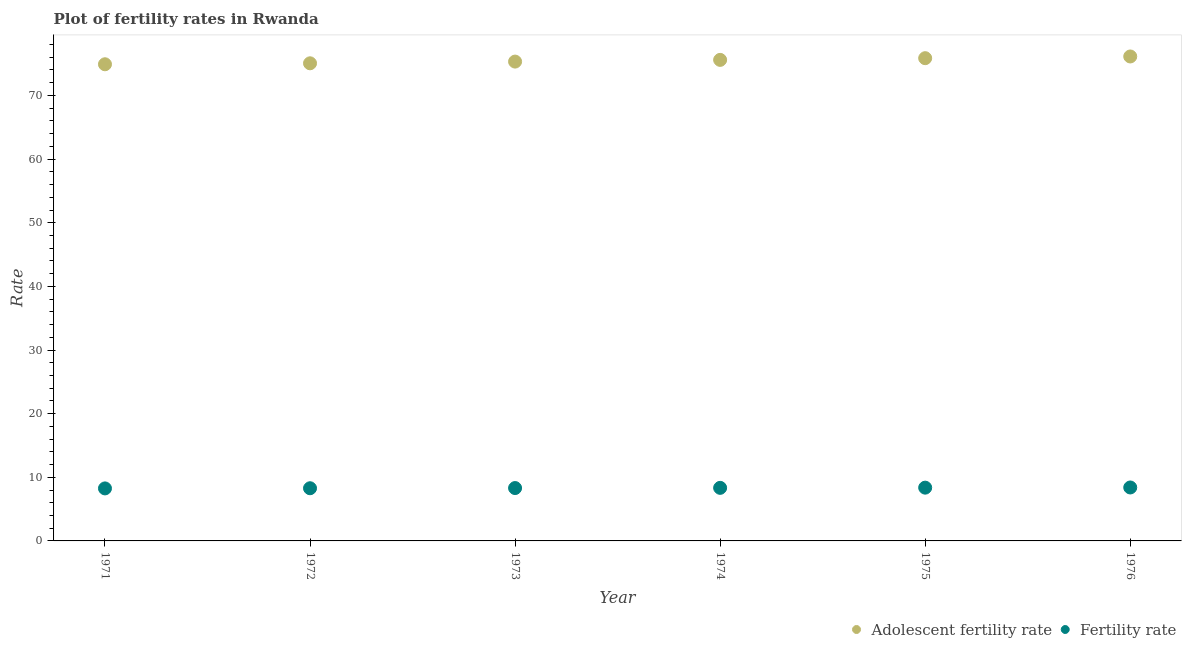What is the fertility rate in 1976?
Keep it short and to the point. 8.4. Across all years, what is the maximum fertility rate?
Your response must be concise. 8.4. Across all years, what is the minimum adolescent fertility rate?
Offer a terse response. 74.9. In which year was the fertility rate maximum?
Ensure brevity in your answer.  1976. In which year was the adolescent fertility rate minimum?
Your response must be concise. 1971. What is the total adolescent fertility rate in the graph?
Your answer should be very brief. 452.85. What is the difference between the fertility rate in 1972 and that in 1973?
Make the answer very short. -0.03. What is the difference between the fertility rate in 1975 and the adolescent fertility rate in 1976?
Your response must be concise. -67.76. What is the average adolescent fertility rate per year?
Your answer should be very brief. 75.47. In the year 1971, what is the difference between the fertility rate and adolescent fertility rate?
Provide a succinct answer. -66.65. In how many years, is the fertility rate greater than 16?
Provide a succinct answer. 0. What is the ratio of the adolescent fertility rate in 1974 to that in 1976?
Give a very brief answer. 0.99. Is the fertility rate in 1974 less than that in 1975?
Make the answer very short. Yes. What is the difference between the highest and the second highest fertility rate?
Your answer should be compact. 0.03. What is the difference between the highest and the lowest fertility rate?
Ensure brevity in your answer.  0.15. In how many years, is the adolescent fertility rate greater than the average adolescent fertility rate taken over all years?
Provide a succinct answer. 3. Is the sum of the fertility rate in 1971 and 1976 greater than the maximum adolescent fertility rate across all years?
Provide a short and direct response. No. Is the fertility rate strictly less than the adolescent fertility rate over the years?
Provide a succinct answer. Yes. How many years are there in the graph?
Keep it short and to the point. 6. Are the values on the major ticks of Y-axis written in scientific E-notation?
Offer a terse response. No. Does the graph contain any zero values?
Your response must be concise. No. Does the graph contain grids?
Keep it short and to the point. No. How are the legend labels stacked?
Offer a terse response. Horizontal. What is the title of the graph?
Provide a short and direct response. Plot of fertility rates in Rwanda. Does "Resident workers" appear as one of the legend labels in the graph?
Your response must be concise. No. What is the label or title of the X-axis?
Provide a succinct answer. Year. What is the label or title of the Y-axis?
Your response must be concise. Rate. What is the Rate in Adolescent fertility rate in 1971?
Your response must be concise. 74.9. What is the Rate in Fertility rate in 1971?
Your answer should be very brief. 8.25. What is the Rate in Adolescent fertility rate in 1972?
Your answer should be very brief. 75.05. What is the Rate in Fertility rate in 1972?
Provide a succinct answer. 8.28. What is the Rate in Adolescent fertility rate in 1973?
Make the answer very short. 75.32. What is the Rate in Fertility rate in 1973?
Your answer should be compact. 8.31. What is the Rate of Adolescent fertility rate in 1974?
Provide a succinct answer. 75.59. What is the Rate in Fertility rate in 1974?
Offer a very short reply. 8.34. What is the Rate of Adolescent fertility rate in 1975?
Your answer should be compact. 75.86. What is the Rate of Fertility rate in 1975?
Provide a short and direct response. 8.37. What is the Rate in Adolescent fertility rate in 1976?
Your answer should be very brief. 76.13. What is the Rate in Fertility rate in 1976?
Provide a succinct answer. 8.4. Across all years, what is the maximum Rate in Adolescent fertility rate?
Your answer should be very brief. 76.13. Across all years, what is the maximum Rate of Fertility rate?
Ensure brevity in your answer.  8.4. Across all years, what is the minimum Rate of Adolescent fertility rate?
Make the answer very short. 74.9. Across all years, what is the minimum Rate in Fertility rate?
Offer a very short reply. 8.25. What is the total Rate of Adolescent fertility rate in the graph?
Ensure brevity in your answer.  452.85. What is the total Rate of Fertility rate in the graph?
Provide a succinct answer. 49.95. What is the difference between the Rate of Adolescent fertility rate in 1971 and that in 1972?
Keep it short and to the point. -0.15. What is the difference between the Rate of Fertility rate in 1971 and that in 1972?
Offer a terse response. -0.03. What is the difference between the Rate in Adolescent fertility rate in 1971 and that in 1973?
Offer a terse response. -0.42. What is the difference between the Rate of Fertility rate in 1971 and that in 1973?
Make the answer very short. -0.06. What is the difference between the Rate in Adolescent fertility rate in 1971 and that in 1974?
Ensure brevity in your answer.  -0.69. What is the difference between the Rate of Fertility rate in 1971 and that in 1974?
Give a very brief answer. -0.09. What is the difference between the Rate in Adolescent fertility rate in 1971 and that in 1975?
Offer a terse response. -0.96. What is the difference between the Rate of Fertility rate in 1971 and that in 1975?
Your answer should be compact. -0.12. What is the difference between the Rate of Adolescent fertility rate in 1971 and that in 1976?
Offer a terse response. -1.23. What is the difference between the Rate of Fertility rate in 1971 and that in 1976?
Your response must be concise. -0.15. What is the difference between the Rate of Adolescent fertility rate in 1972 and that in 1973?
Offer a terse response. -0.27. What is the difference between the Rate in Fertility rate in 1972 and that in 1973?
Keep it short and to the point. -0.03. What is the difference between the Rate in Adolescent fertility rate in 1972 and that in 1974?
Offer a very short reply. -0.54. What is the difference between the Rate of Fertility rate in 1972 and that in 1974?
Give a very brief answer. -0.06. What is the difference between the Rate of Adolescent fertility rate in 1972 and that in 1975?
Make the answer very short. -0.8. What is the difference between the Rate in Fertility rate in 1972 and that in 1975?
Ensure brevity in your answer.  -0.09. What is the difference between the Rate in Adolescent fertility rate in 1972 and that in 1976?
Make the answer very short. -1.07. What is the difference between the Rate of Fertility rate in 1972 and that in 1976?
Your answer should be compact. -0.12. What is the difference between the Rate of Adolescent fertility rate in 1973 and that in 1974?
Your answer should be compact. -0.27. What is the difference between the Rate of Fertility rate in 1973 and that in 1974?
Keep it short and to the point. -0.03. What is the difference between the Rate of Adolescent fertility rate in 1973 and that in 1975?
Provide a succinct answer. -0.54. What is the difference between the Rate of Fertility rate in 1973 and that in 1975?
Keep it short and to the point. -0.06. What is the difference between the Rate of Adolescent fertility rate in 1973 and that in 1976?
Offer a very short reply. -0.8. What is the difference between the Rate in Fertility rate in 1973 and that in 1976?
Your response must be concise. -0.09. What is the difference between the Rate of Adolescent fertility rate in 1974 and that in 1975?
Keep it short and to the point. -0.27. What is the difference between the Rate in Fertility rate in 1974 and that in 1975?
Your response must be concise. -0.03. What is the difference between the Rate in Adolescent fertility rate in 1974 and that in 1976?
Provide a short and direct response. -0.54. What is the difference between the Rate of Fertility rate in 1974 and that in 1976?
Provide a succinct answer. -0.06. What is the difference between the Rate in Adolescent fertility rate in 1975 and that in 1976?
Make the answer very short. -0.27. What is the difference between the Rate in Fertility rate in 1975 and that in 1976?
Provide a short and direct response. -0.03. What is the difference between the Rate in Adolescent fertility rate in 1971 and the Rate in Fertility rate in 1972?
Offer a very short reply. 66.62. What is the difference between the Rate of Adolescent fertility rate in 1971 and the Rate of Fertility rate in 1973?
Keep it short and to the point. 66.59. What is the difference between the Rate in Adolescent fertility rate in 1971 and the Rate in Fertility rate in 1974?
Offer a terse response. 66.56. What is the difference between the Rate in Adolescent fertility rate in 1971 and the Rate in Fertility rate in 1975?
Provide a succinct answer. 66.53. What is the difference between the Rate in Adolescent fertility rate in 1971 and the Rate in Fertility rate in 1976?
Provide a succinct answer. 66.5. What is the difference between the Rate in Adolescent fertility rate in 1972 and the Rate in Fertility rate in 1973?
Make the answer very short. 66.75. What is the difference between the Rate in Adolescent fertility rate in 1972 and the Rate in Fertility rate in 1974?
Your answer should be very brief. 66.71. What is the difference between the Rate of Adolescent fertility rate in 1972 and the Rate of Fertility rate in 1975?
Provide a short and direct response. 66.68. What is the difference between the Rate in Adolescent fertility rate in 1972 and the Rate in Fertility rate in 1976?
Offer a terse response. 66.65. What is the difference between the Rate in Adolescent fertility rate in 1973 and the Rate in Fertility rate in 1974?
Your answer should be very brief. 66.98. What is the difference between the Rate in Adolescent fertility rate in 1973 and the Rate in Fertility rate in 1975?
Your answer should be compact. 66.95. What is the difference between the Rate in Adolescent fertility rate in 1973 and the Rate in Fertility rate in 1976?
Give a very brief answer. 66.92. What is the difference between the Rate in Adolescent fertility rate in 1974 and the Rate in Fertility rate in 1975?
Your response must be concise. 67.22. What is the difference between the Rate in Adolescent fertility rate in 1974 and the Rate in Fertility rate in 1976?
Your answer should be very brief. 67.19. What is the difference between the Rate in Adolescent fertility rate in 1975 and the Rate in Fertility rate in 1976?
Provide a short and direct response. 67.46. What is the average Rate in Adolescent fertility rate per year?
Offer a very short reply. 75.47. What is the average Rate of Fertility rate per year?
Ensure brevity in your answer.  8.32. In the year 1971, what is the difference between the Rate in Adolescent fertility rate and Rate in Fertility rate?
Your answer should be very brief. 66.65. In the year 1972, what is the difference between the Rate of Adolescent fertility rate and Rate of Fertility rate?
Ensure brevity in your answer.  66.78. In the year 1973, what is the difference between the Rate in Adolescent fertility rate and Rate in Fertility rate?
Offer a terse response. 67.01. In the year 1974, what is the difference between the Rate in Adolescent fertility rate and Rate in Fertility rate?
Your answer should be compact. 67.25. In the year 1975, what is the difference between the Rate of Adolescent fertility rate and Rate of Fertility rate?
Offer a terse response. 67.49. In the year 1976, what is the difference between the Rate of Adolescent fertility rate and Rate of Fertility rate?
Your answer should be compact. 67.73. What is the ratio of the Rate of Fertility rate in 1971 to that in 1972?
Ensure brevity in your answer.  1. What is the ratio of the Rate in Adolescent fertility rate in 1971 to that in 1974?
Make the answer very short. 0.99. What is the ratio of the Rate of Adolescent fertility rate in 1971 to that in 1975?
Your response must be concise. 0.99. What is the ratio of the Rate in Fertility rate in 1971 to that in 1975?
Provide a succinct answer. 0.99. What is the ratio of the Rate in Adolescent fertility rate in 1971 to that in 1976?
Offer a very short reply. 0.98. What is the ratio of the Rate of Fertility rate in 1971 to that in 1976?
Your answer should be compact. 0.98. What is the ratio of the Rate in Fertility rate in 1972 to that in 1974?
Ensure brevity in your answer.  0.99. What is the ratio of the Rate in Fertility rate in 1972 to that in 1975?
Offer a very short reply. 0.99. What is the ratio of the Rate in Adolescent fertility rate in 1972 to that in 1976?
Make the answer very short. 0.99. What is the ratio of the Rate in Fertility rate in 1972 to that in 1976?
Your answer should be compact. 0.99. What is the ratio of the Rate of Fertility rate in 1973 to that in 1974?
Offer a terse response. 1. What is the ratio of the Rate in Adolescent fertility rate in 1973 to that in 1975?
Your answer should be compact. 0.99. What is the ratio of the Rate in Adolescent fertility rate in 1973 to that in 1976?
Keep it short and to the point. 0.99. What is the ratio of the Rate of Adolescent fertility rate in 1974 to that in 1975?
Your response must be concise. 1. What is the ratio of the Rate of Fertility rate in 1974 to that in 1975?
Your answer should be compact. 1. What is the ratio of the Rate of Adolescent fertility rate in 1974 to that in 1976?
Keep it short and to the point. 0.99. What is the ratio of the Rate in Adolescent fertility rate in 1975 to that in 1976?
Your response must be concise. 1. What is the difference between the highest and the second highest Rate in Adolescent fertility rate?
Ensure brevity in your answer.  0.27. What is the difference between the highest and the second highest Rate in Fertility rate?
Your answer should be compact. 0.03. What is the difference between the highest and the lowest Rate in Adolescent fertility rate?
Offer a terse response. 1.23. What is the difference between the highest and the lowest Rate in Fertility rate?
Keep it short and to the point. 0.15. 